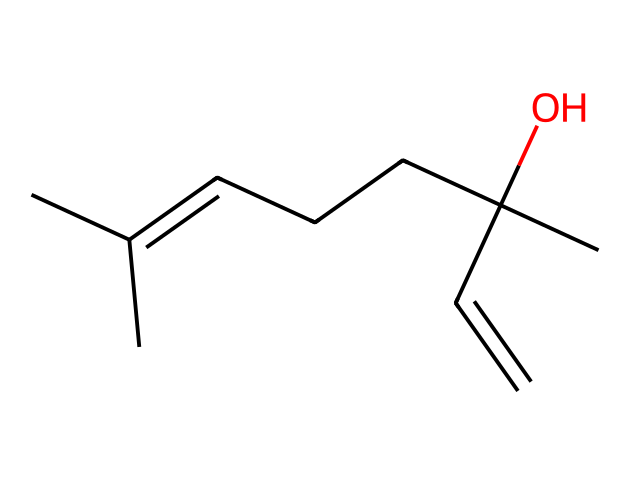how many carbon atoms are in linalool? From the SMILES representation, "CC(=CCCC(C)(O)C=C)C", we can systematically count the carbon atoms present. Each 'C' in the structure represents a carbon atom. Counting them yields a total of 10 carbon atoms.
Answer: 10 how many hydroxyl (OH) groups does linalool have? In the given SMILES, the '(O)' indicates the presence of a hydroxyl group (–OH). Observing the structure, there is only one hydroxyl group attached to the carbon chain.
Answer: 1 what type of compound is linalool? Linalool is categorized as a terpene due to its molecular structure characterized by a series of carbon and hydrogen atoms arranged in a specific pattern typical of terpenes, which are known for their aromatic qualities and found in essential oils.
Answer: terpene what functional group is present in linalool based on its structure? The structure features an alcohol functional group due to the presence of the hydroxyl group (–OH). This can be deduced by seeing 'O' attached to a carbon atom in the structure, classifying it specifically as a primary alcohol.
Answer: alcohol how many double bonds are in linalool's structure? By analyzing the double bonds indicated by "=" in the SMILES, we can identify that there are two double bonds in the structure of linalool. The presence of the "=" sign corresponds to unsaturation in the carbon chain.
Answer: 2 what implications does the presence of a hydroxyl group have on linalool's properties? The presence of the hydroxyl group (–OH) increases linalool's polarity, enhancing its solubility in water compared to non-polar compounds. This also allows it to participate in hydrogen bonding, affecting its interaction with biological systems.
Answer: increases polarity is linalool a saturated or unsaturated compound? By examining the presence of double bonds (indicated by "=") in the structure, we can conclude that linalool is unsaturated, as it contains multiple double bonds in its carbon backbone. This unsaturation reflects its reactivity compared to saturated compounds.
Answer: unsaturated 